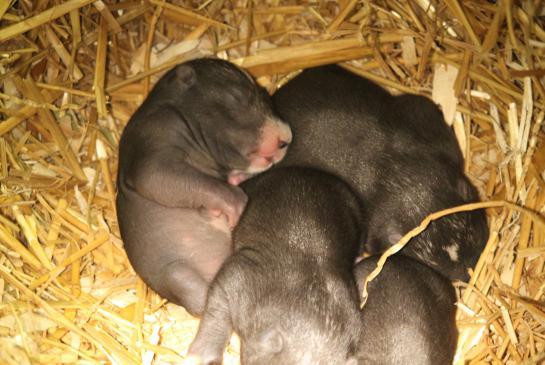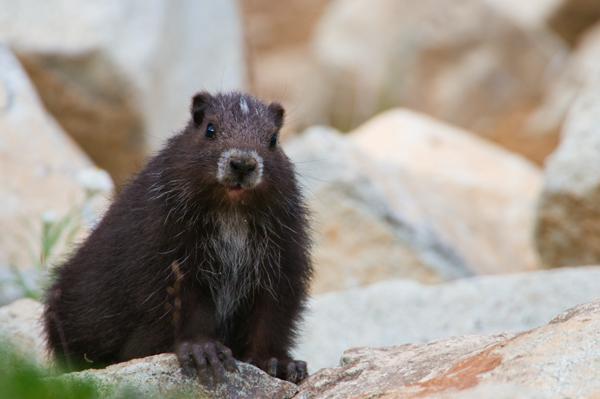The first image is the image on the left, the second image is the image on the right. Analyze the images presented: Is the assertion "There are a total of 3 young capybara." valid? Answer yes or no. No. The first image is the image on the left, the second image is the image on the right. Analyze the images presented: Is the assertion "there are 3 gophers on rocky surfaces in the image pair" valid? Answer yes or no. No. 